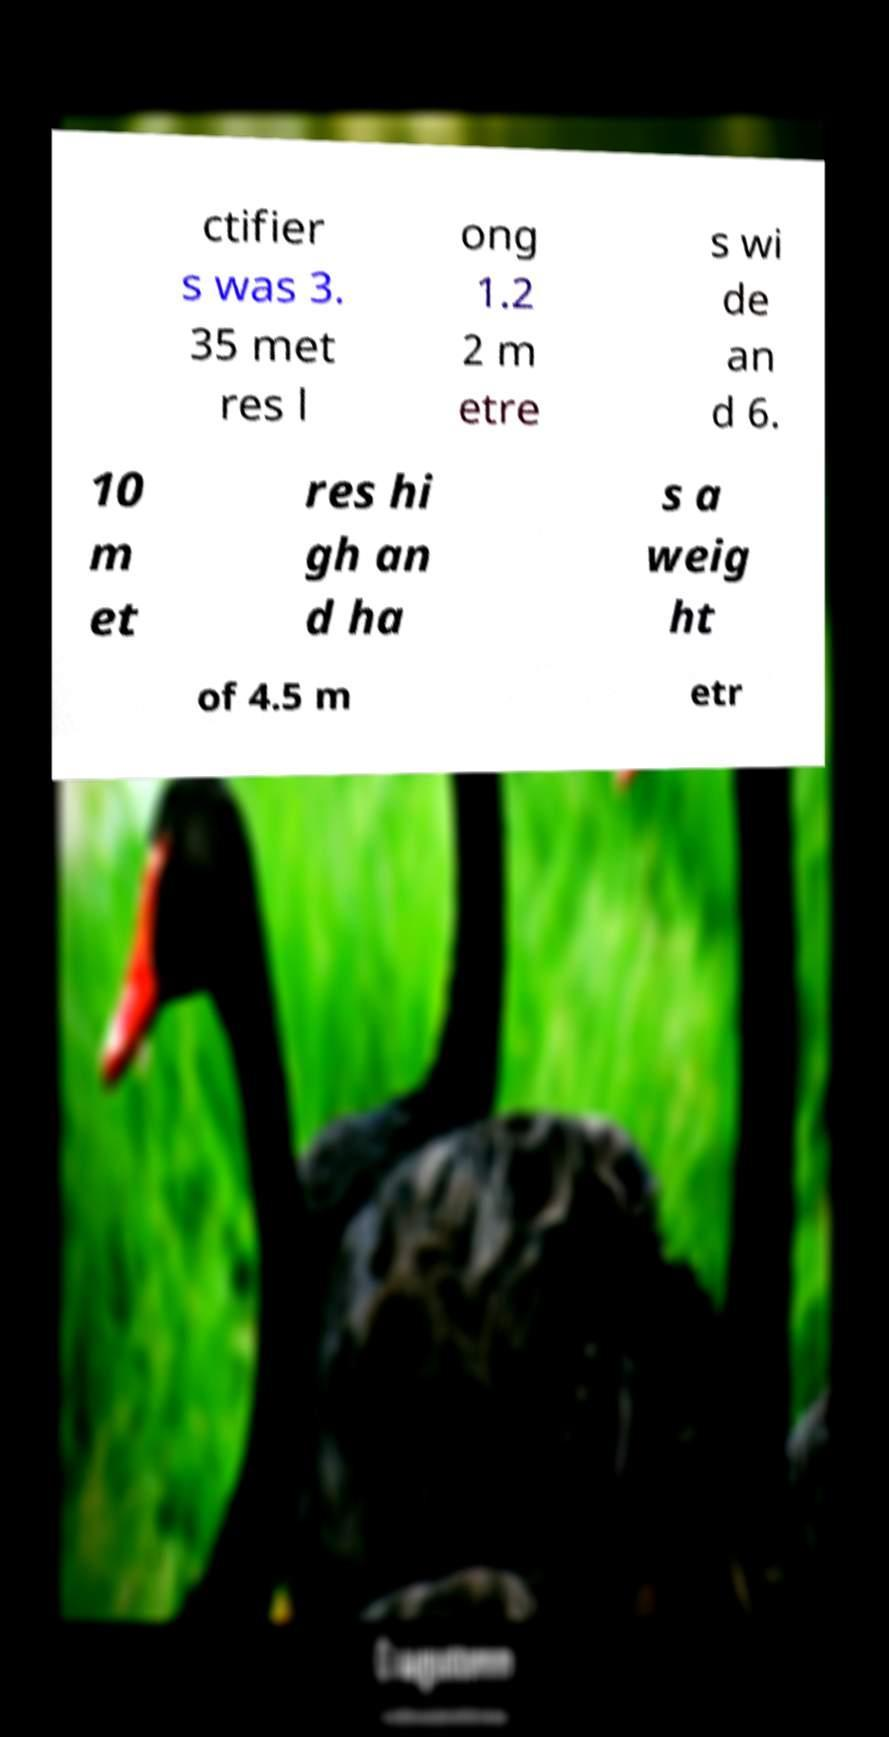Could you assist in decoding the text presented in this image and type it out clearly? ctifier s was 3. 35 met res l ong 1.2 2 m etre s wi de an d 6. 10 m et res hi gh an d ha s a weig ht of 4.5 m etr 